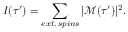<formula> <loc_0><loc_0><loc_500><loc_500>I ( \tau ^ { \prime } ) = \sum _ { e x t . \, s p i n s } | \ m a t h s c r { M } ( \tau ^ { \prime } ) | ^ { 2 } .</formula> 